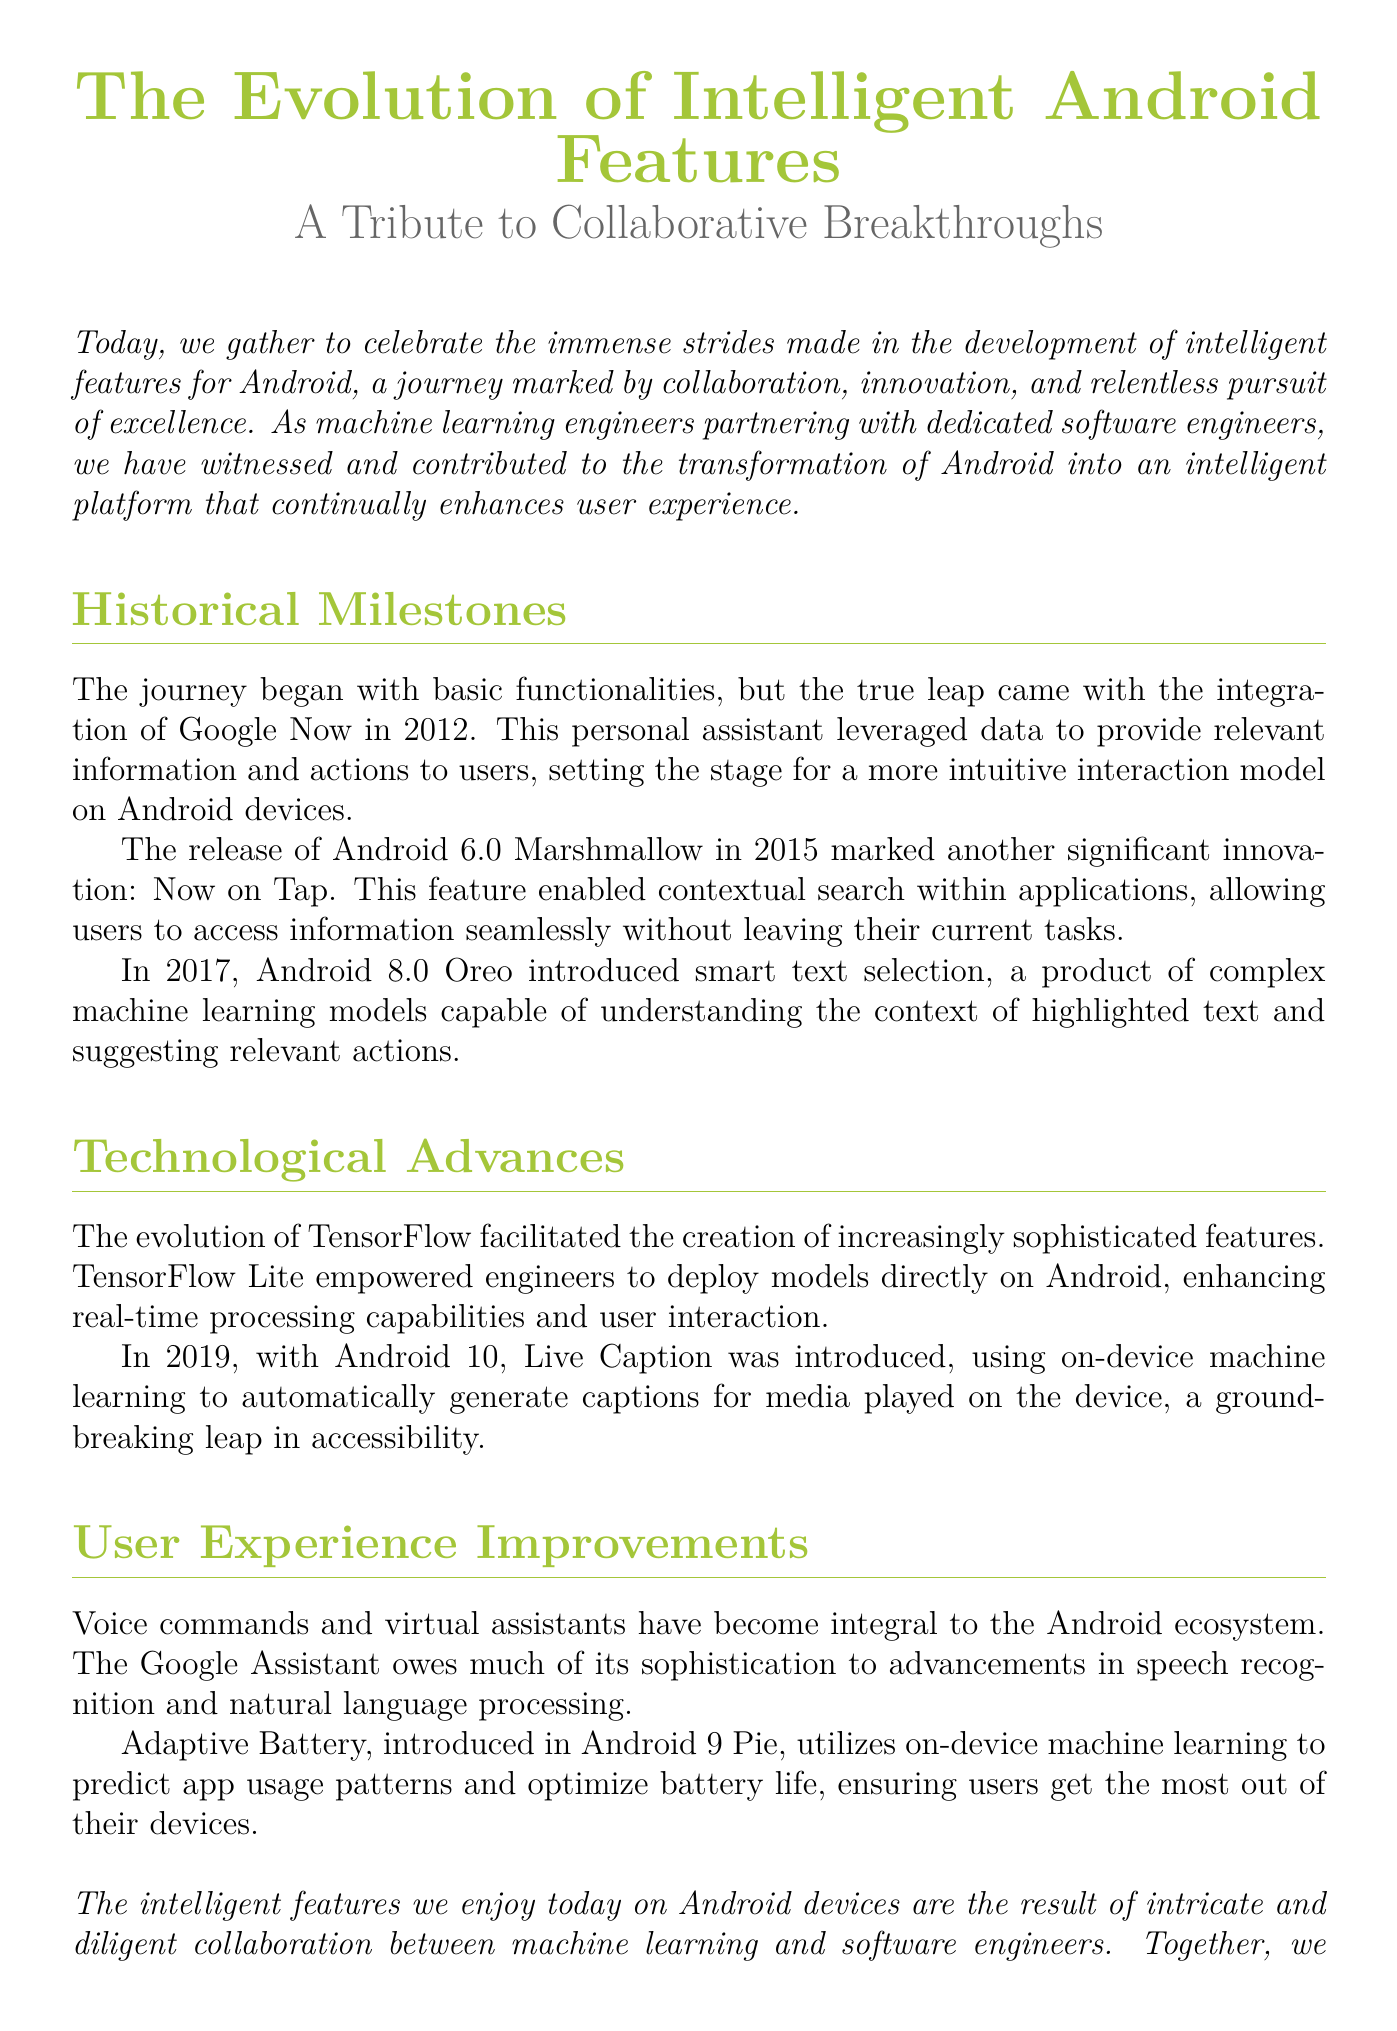what year was Google Now integrated into Android? Google Now was integrated in 2012, marking a significant step in the evolution of intelligent features on Android.
Answer: 2012 what significant feature was introduced in Android 6.0 Marshmallow? Android 6.0 Marshmallow introduced the Now on Tap feature, which enabled contextual search within applications.
Answer: Now on Tap which machine learning framework is mentioned as facilitating the development of Android features? TensorFlow is mentioned as the framework that facilitated the creation of sophisticated features for Android devices.
Answer: TensorFlow what feature was introduced in Android 10? The feature introduced in Android 10 was Live Caption, which automatically generates captions for media played on the device.
Answer: Live Caption how does Adaptive Battery optimize battery life? Adaptive Battery uses on-device machine learning to predict app usage patterns and optimize battery life accordingly.
Answer: Predict app usage patterns what is the underlying technology for the Google Assistant? The Google Assistant relies on advancements in speech recognition and natural language processing to achieve its sophistication.
Answer: Speech recognition and natural language processing what is the main purpose of the tribute in the eulogy? The tribute emphasizes the collaboration and breakthroughs between machine learning and software engineers in enhancing the Android platform.
Answer: Collaboration and breakthroughs what does the document emphasize regarding the future of intelligent features? The document emphasizes continuing to push the boundaries of technology to create more intelligent and user-centric features.
Answer: Push boundaries of technology 